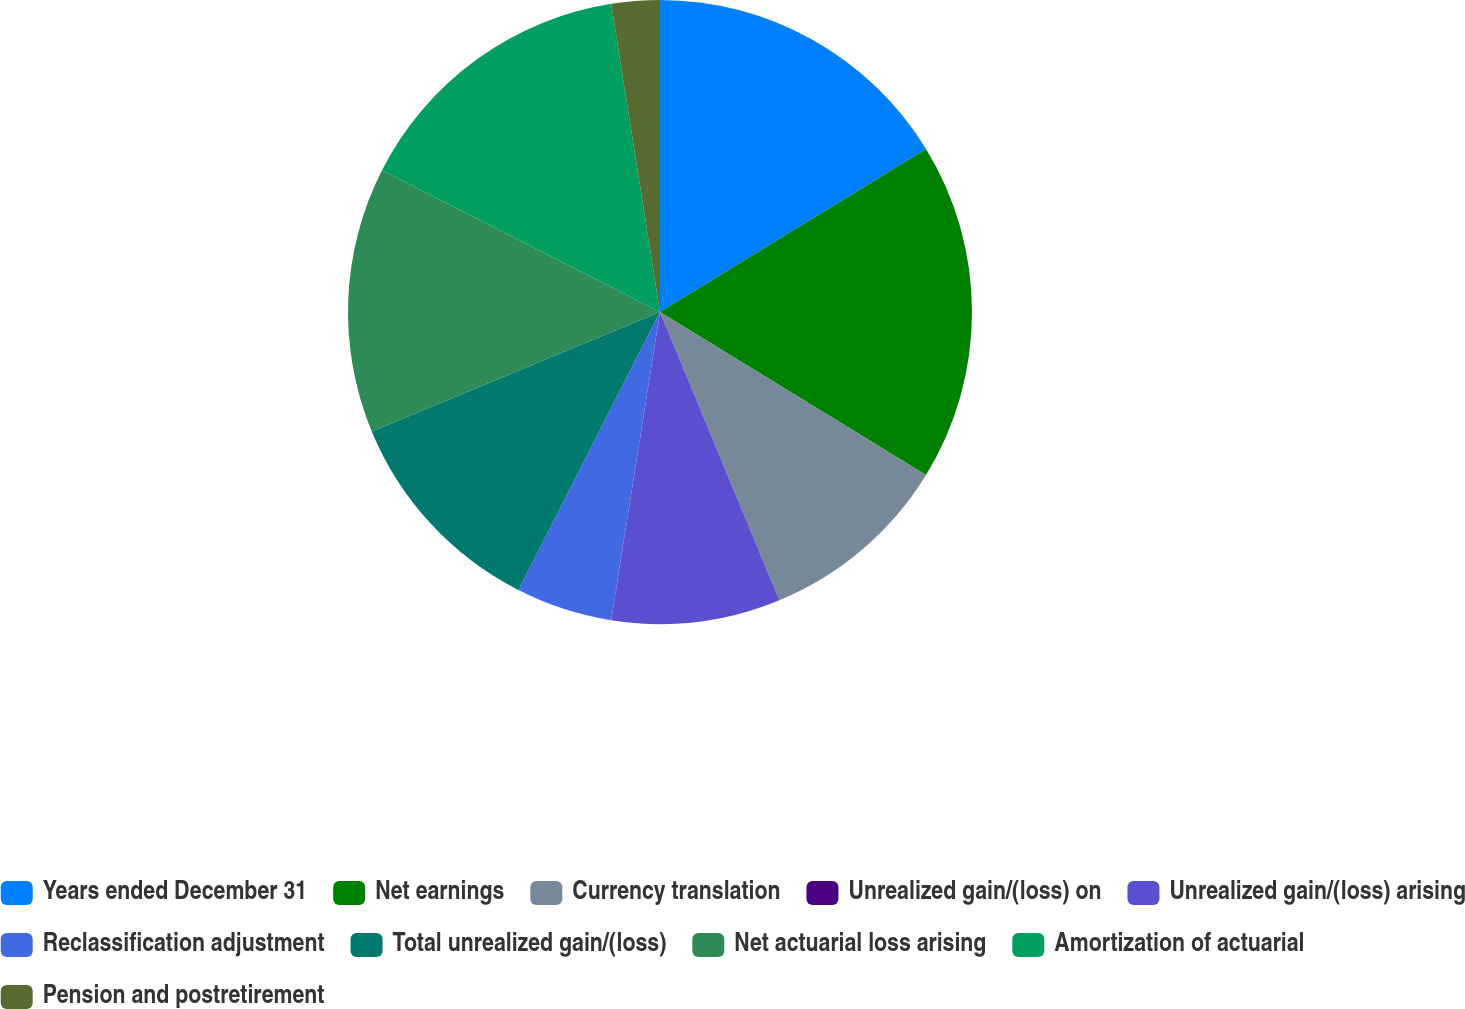<chart> <loc_0><loc_0><loc_500><loc_500><pie_chart><fcel>Years ended December 31<fcel>Net earnings<fcel>Currency translation<fcel>Unrealized gain/(loss) on<fcel>Unrealized gain/(loss) arising<fcel>Reclassification adjustment<fcel>Total unrealized gain/(loss)<fcel>Net actuarial loss arising<fcel>Amortization of actuarial<fcel>Pension and postretirement<nl><fcel>16.25%<fcel>17.5%<fcel>10.0%<fcel>0.0%<fcel>8.75%<fcel>5.0%<fcel>11.25%<fcel>13.75%<fcel>15.0%<fcel>2.5%<nl></chart> 